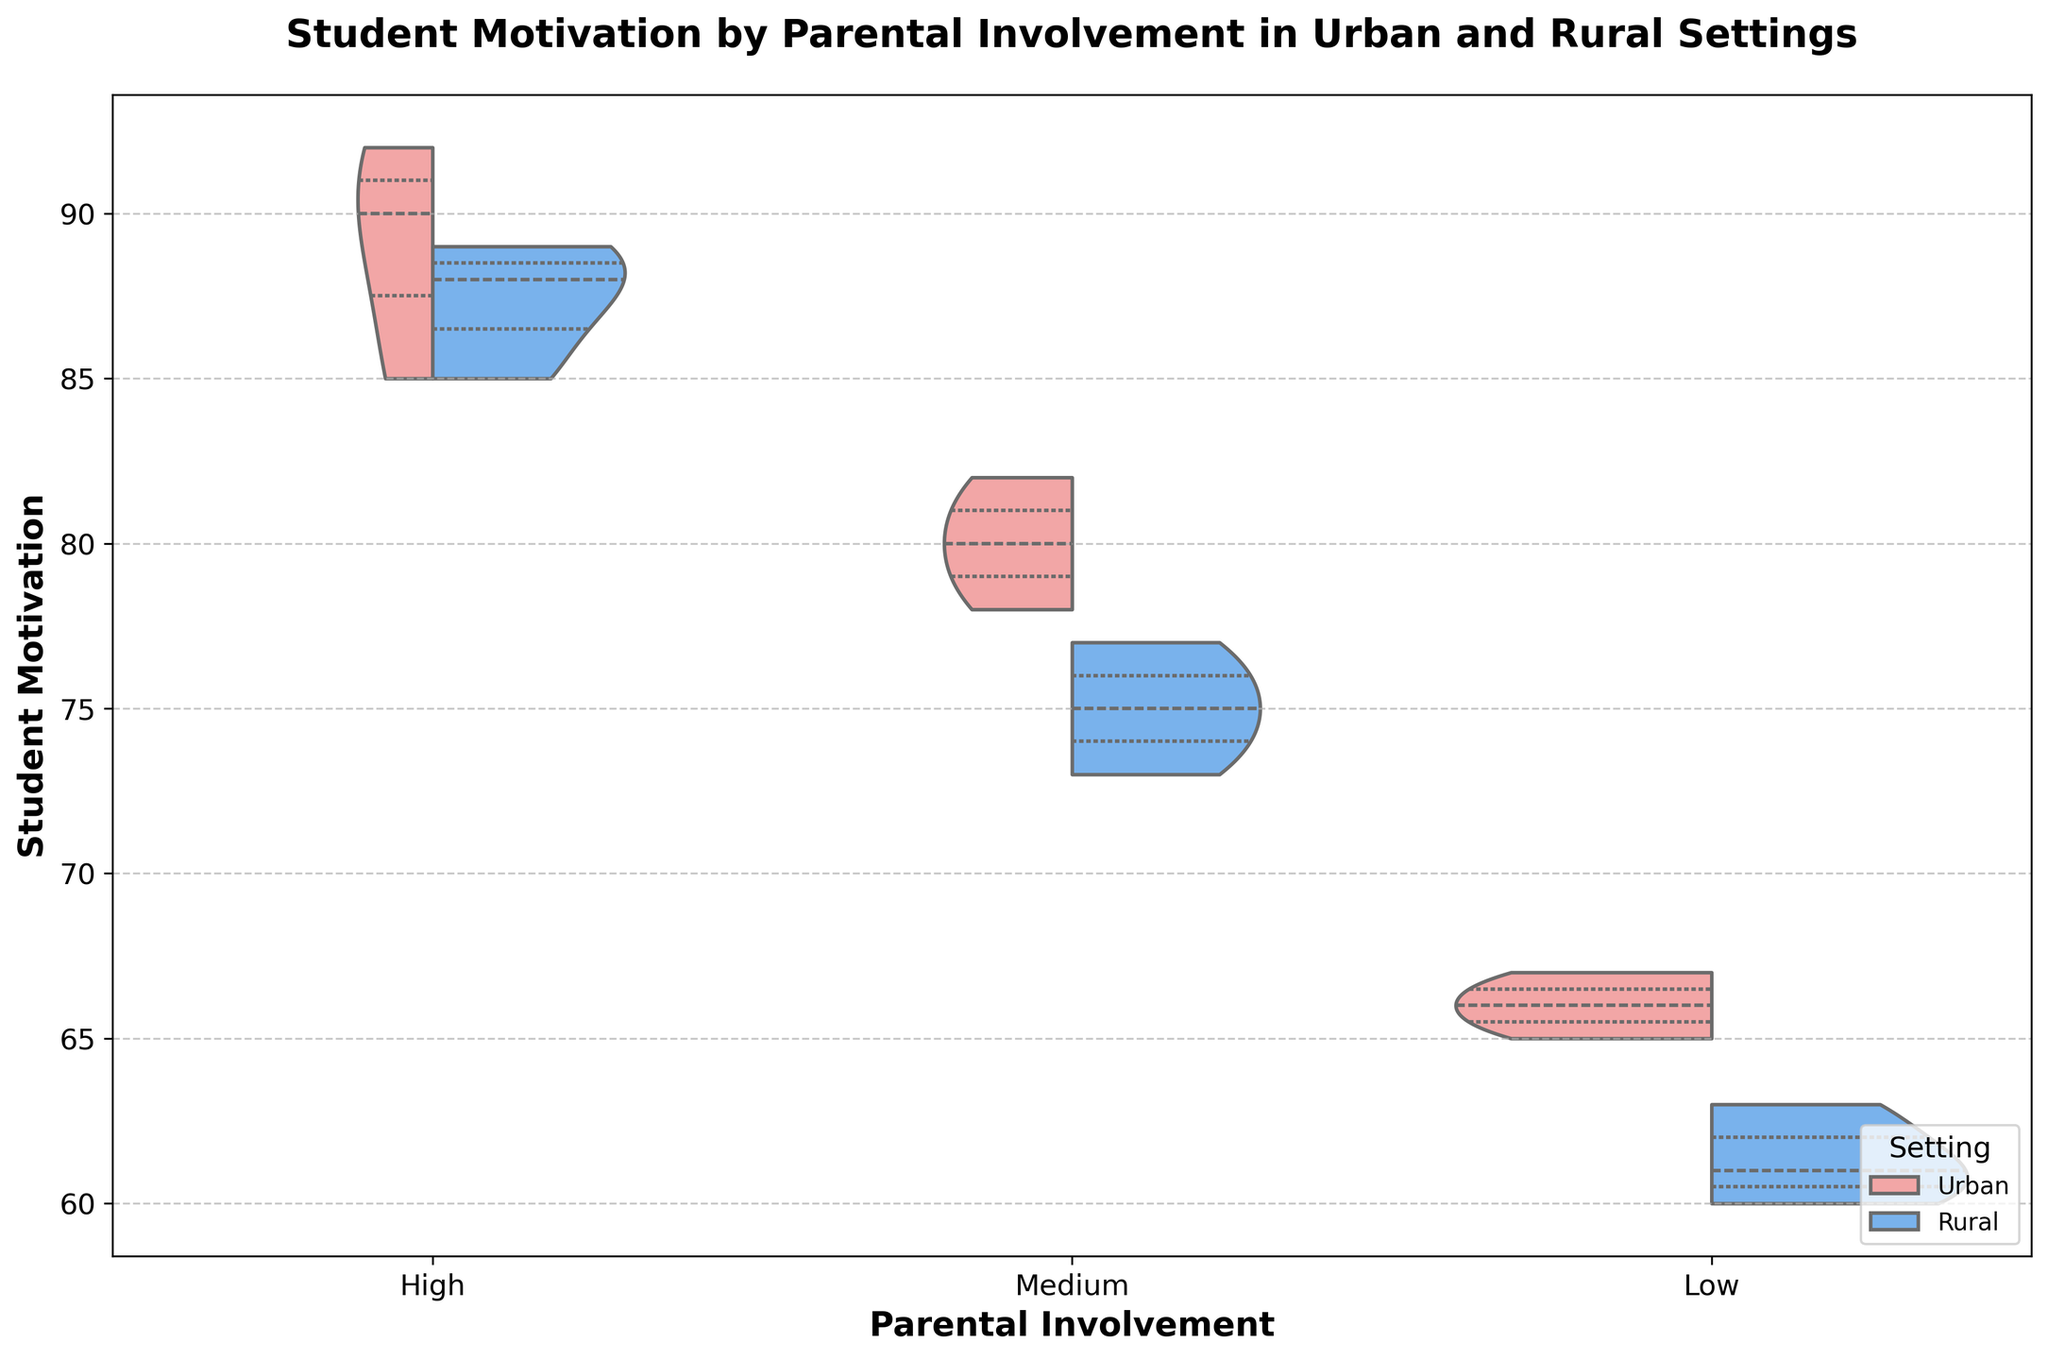What is the title of the figure? The title is displayed at the top of the plot. It reads "Student Motivation by Parental Involvement in Urban and Rural Settings."
Answer: Student Motivation by Parental Involvement in Urban and Rural Settings How is the student motivation in Urban settings for low parental involvement compared to high parental involvement? By looking at the different sections of the violin plot, the student motivation is lower for low parental involvement compared to high parental involvement in Urban settings, with values around 65-67 for low and around 85-90 for high.
Answer: Lower Between Urban and Rural settings, which one has a higher peak of student motivation for medium parental involvement? By examining the peaks of the violin plots for medium parental involvement, Urban settings show a higher peak with student motivation around 80-82, compared to about 73-77 in Rural settings.
Answer: Urban Are there noticeable differences in student motivation distribution for high parental involvement between Urban and Rural settings? The high parental involvement section of the violin plot shows that Urban settings have a slightly wider distribution of student motivation values (85-92), compared to Rural settings (85-89).
Answer: Yes Which setting shows a wider range of student motivation for medium parental involvement? The width of the violin plot for medium parental involvement indicates the data spread. Urban settings have a slightly wider range of student motivation (78-82) compared to Rural settings (73-77).
Answer: Urban For low parental involvement, which setting has a higher quartile range of student motivation? The inner lines of the violin plot represent the quartiles. In Urban settings, the quartile range appears slightly higher (65-67) compared to Rural settings (60-63).
Answer: Urban Is there any overlap in the distribution of student motivation between Urban and Rural settings for high parental involvement? The split violin plot shows that both Urban and Rural settings have an overlapping range of student motivation values from approximately 85 to 89 for high parental involvement.
Answer: Yes What is the observed impact of high parental involvement on student motivation in Rural settings compared to medium and low parental involvement? The Rural student motivation is highest with high parental involvement (85-89), followed by medium (73-77), and lowest with low parental involvement (60-63), indicating that higher parental involvement is linked with higher motivation.
Answer: Higher In Urban settings, which category of parental involvement shows the most symmetry in the violin plot? The symmetry of the violin plot indicates balanced data distribution. The high parental involvement category in Urban settings shows the most symmetry, with a more evenly distributed range around the median.
Answer: High 